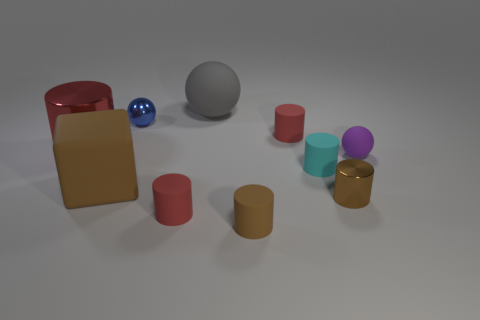Subtract all red cylinders. How many were subtracted if there are1red cylinders left? 2 Subtract all gray spheres. How many brown cylinders are left? 2 Subtract all cyan cylinders. How many cylinders are left? 5 Subtract all brown cylinders. How many cylinders are left? 4 Subtract 2 spheres. How many spheres are left? 1 Subtract all blue spheres. Subtract all blue blocks. How many spheres are left? 2 Subtract all rubber balls. Subtract all big yellow cubes. How many objects are left? 8 Add 8 brown cylinders. How many brown cylinders are left? 10 Add 1 balls. How many balls exist? 4 Subtract 2 brown cylinders. How many objects are left? 8 